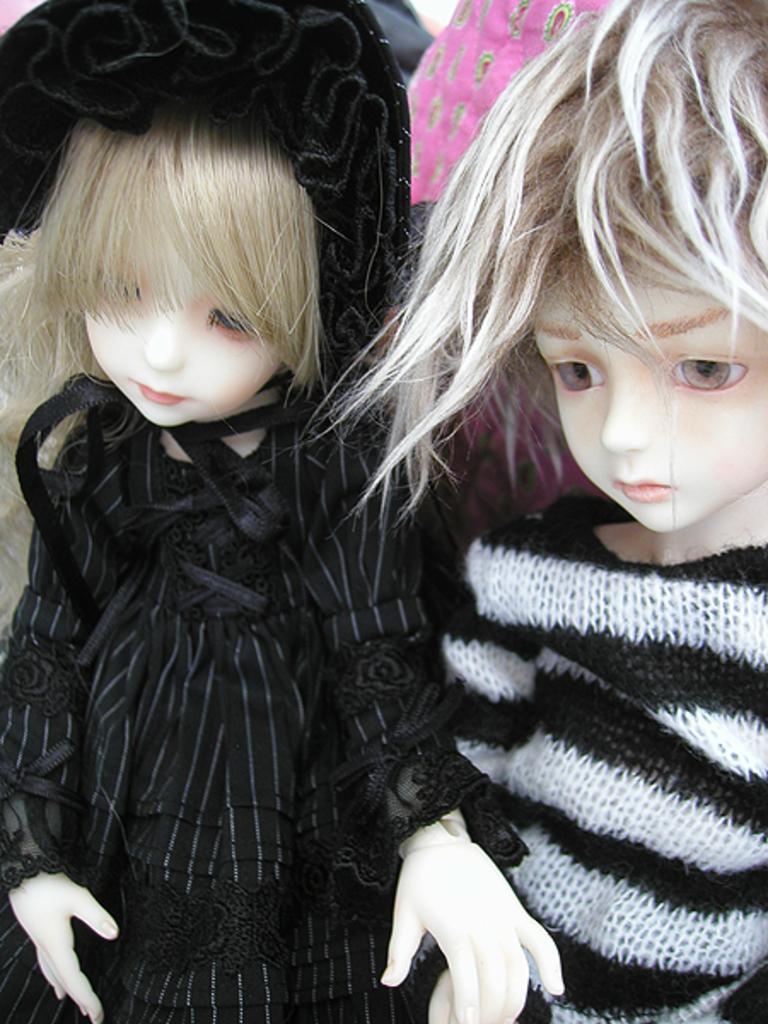In one or two sentences, can you explain what this image depicts? In this image I can see two dolls which are in black and white color. I can see the pink and grey color background. 